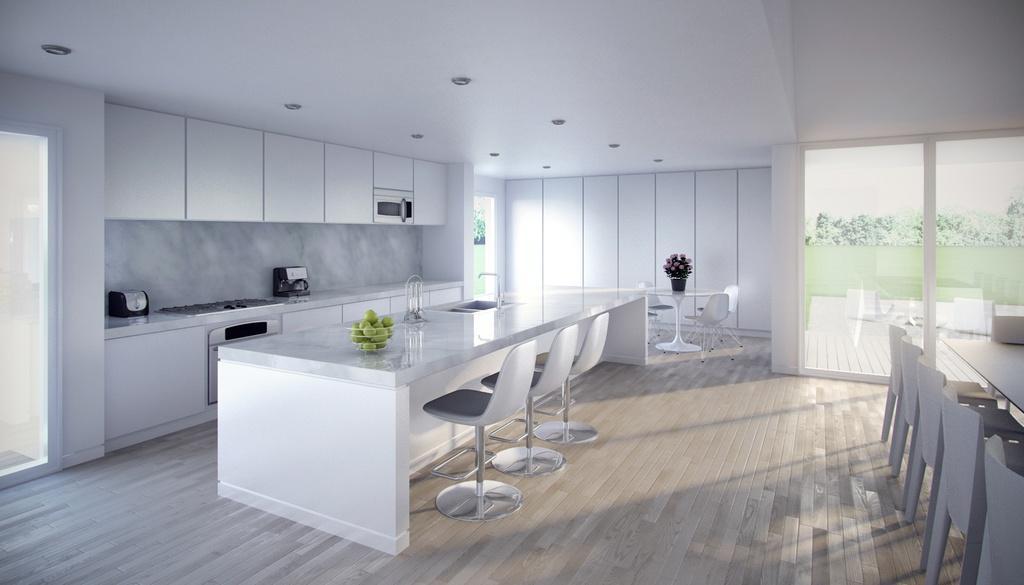In one or two sentences, can you explain what this image depicts? This is a room. On the left side there is a door. Near to that there is a table. On that there is a stove and some other item. Also there is a cupboard. There is another table. On that there is a bowl with fruits. Near to that there are chairs. In the back there is a dining table. On that there is a pot with flowers. Near to that there are chairs. On the right side there is a table with chairs. In the back there is a glass door. Through that we can see trees. On the ceiling there are lights. 